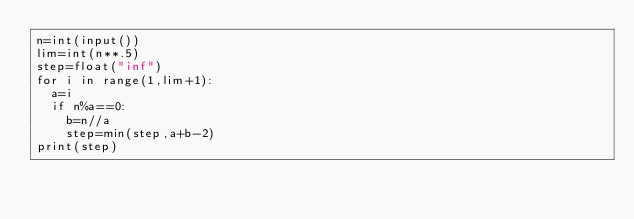<code> <loc_0><loc_0><loc_500><loc_500><_Python_>n=int(input())
lim=int(n**.5)
step=float("inf")
for i in range(1,lim+1):
  a=i
  if n%a==0:
    b=n//a
    step=min(step,a+b-2)
print(step)</code> 